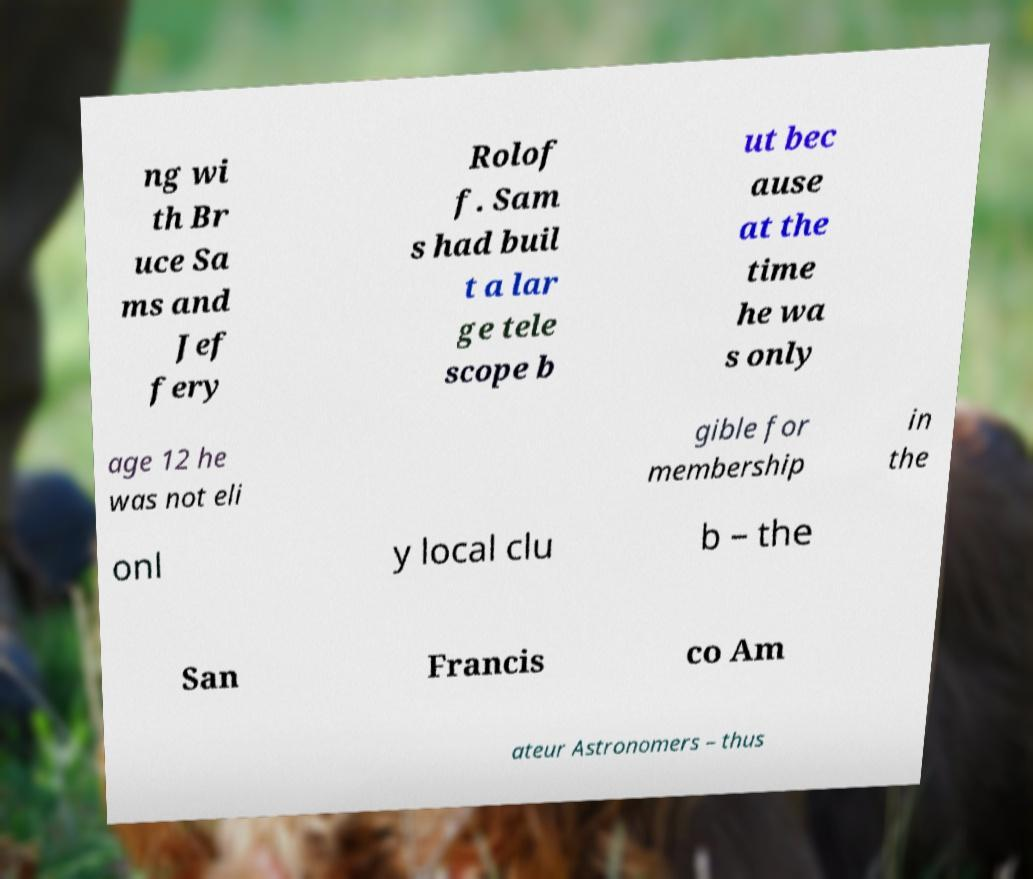Please identify and transcribe the text found in this image. ng wi th Br uce Sa ms and Jef fery Rolof f. Sam s had buil t a lar ge tele scope b ut bec ause at the time he wa s only age 12 he was not eli gible for membership in the onl y local clu b – the San Francis co Am ateur Astronomers – thus 